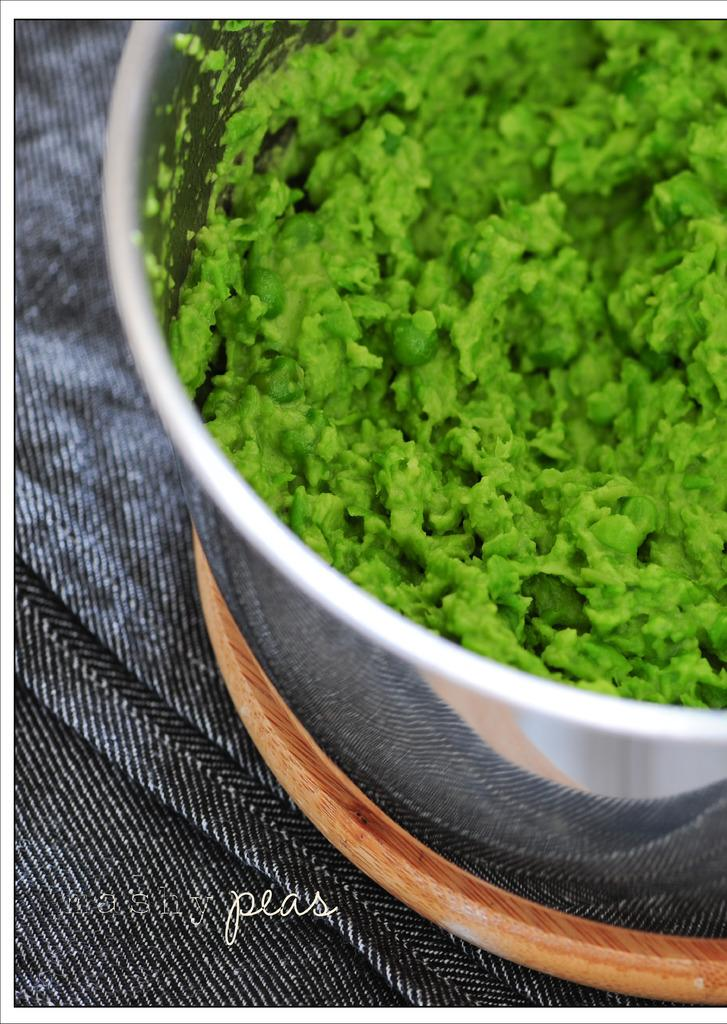What type of food item is in the bowl in the image? The specific type of food item is not mentioned, but there is a food item in a bowl in the image. What can be seen at the bottom of the image? A cloth, a wooden object, and a watermark are visible at the bottom of the image. What type of whip is being used by the father in the image? There is no father or whip present in the image. 